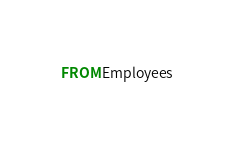Convert code to text. <code><loc_0><loc_0><loc_500><loc_500><_SQL_>FROM Employees</code> 